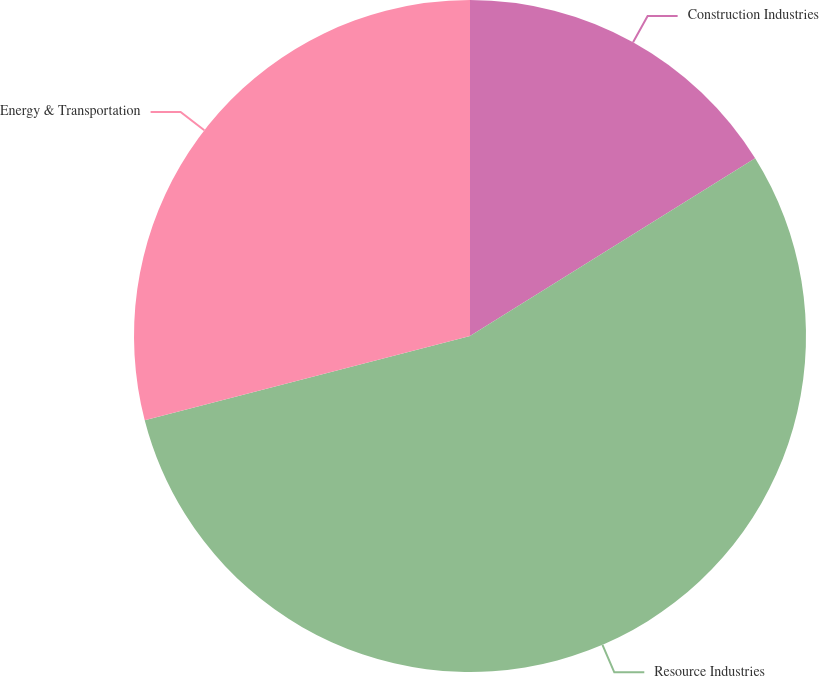<chart> <loc_0><loc_0><loc_500><loc_500><pie_chart><fcel>Construction Industries<fcel>Resource Industries<fcel>Energy & Transportation<nl><fcel>16.13%<fcel>54.84%<fcel>29.03%<nl></chart> 